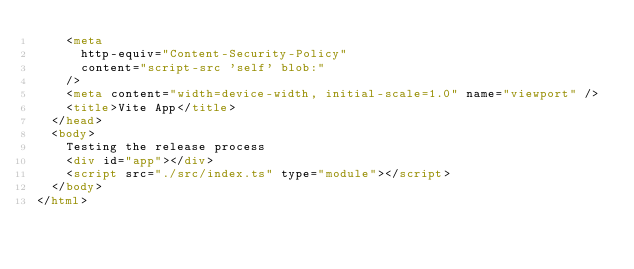Convert code to text. <code><loc_0><loc_0><loc_500><loc_500><_HTML_>    <meta
      http-equiv="Content-Security-Policy"
      content="script-src 'self' blob:"
    />
    <meta content="width=device-width, initial-scale=1.0" name="viewport" />
    <title>Vite App</title>
  </head>
  <body>
    Testing the release process
    <div id="app"></div>
    <script src="./src/index.ts" type="module"></script>
  </body>
</html>
</code> 